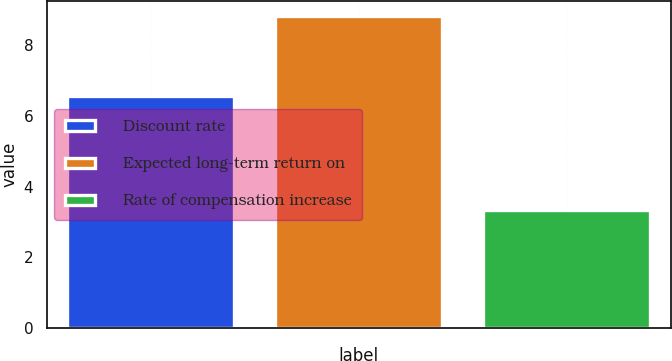Convert chart. <chart><loc_0><loc_0><loc_500><loc_500><bar_chart><fcel>Discount rate<fcel>Expected long-term return on<fcel>Rate of compensation increase<nl><fcel>6.56<fcel>8.81<fcel>3.33<nl></chart> 